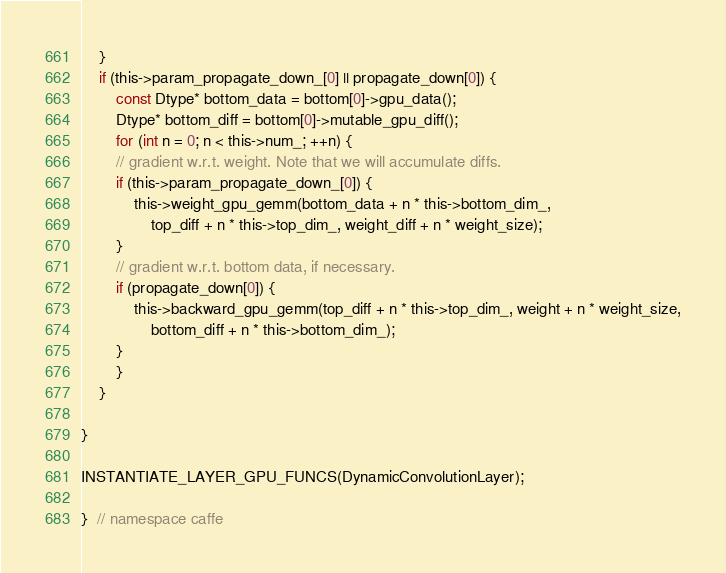Convert code to text. <code><loc_0><loc_0><loc_500><loc_500><_Cuda_>	}
	if (this->param_propagate_down_[0] || propagate_down[0]) {
		const Dtype* bottom_data = bottom[0]->gpu_data();
		Dtype* bottom_diff = bottom[0]->mutable_gpu_diff();
		for (int n = 0; n < this->num_; ++n) {
		// gradient w.r.t. weight. Note that we will accumulate diffs.
		if (this->param_propagate_down_[0]) {
			this->weight_gpu_gemm(bottom_data + n * this->bottom_dim_,
				top_diff + n * this->top_dim_, weight_diff + n * weight_size);
		}
		// gradient w.r.t. bottom data, if necessary.
		if (propagate_down[0]) {
			this->backward_gpu_gemm(top_diff + n * this->top_dim_, weight + n * weight_size,
				bottom_diff + n * this->bottom_dim_);
		}
		}
	}
 
}

INSTANTIATE_LAYER_GPU_FUNCS(DynamicConvolutionLayer);

}  // namespace caffe
</code> 